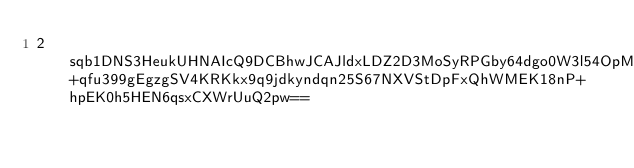Convert code to text. <code><loc_0><loc_0><loc_500><loc_500><_SML_>2sqb1DNS3HeukUHNAIcQ9DCBhwJCAJldxLDZ2D3MoSyRPGby64dgo0W3l54OpMlsSFKB9yUM2RfWnxf47ScUllzWAVHtA7AAFPcGUfzRHpzzvWOdmXwlAkErPVKhP4+qfu399gEgzgSV4KRKkx9q9jdkyndqn25S67NXVStDpFxQhWMEK18nP+hpEK0h5HEN6qsxCXWrUuQ2pw==</code> 